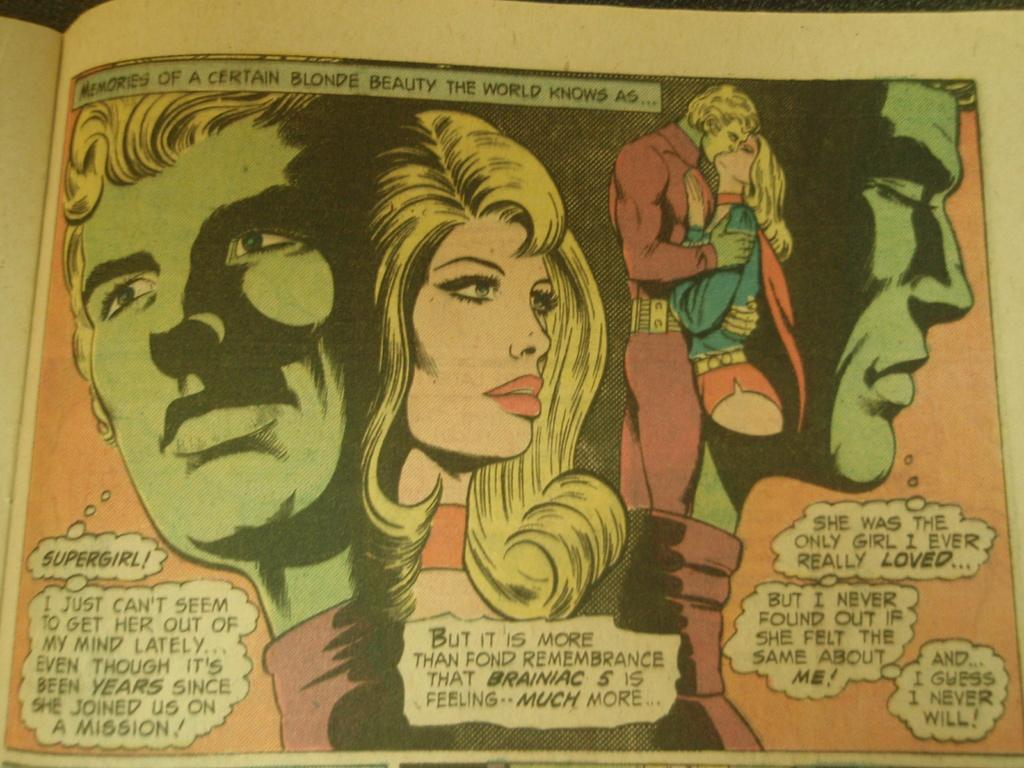<image>
Write a terse but informative summary of the picture. A superhero muses about his feelings about Supergirl in a comic book. 